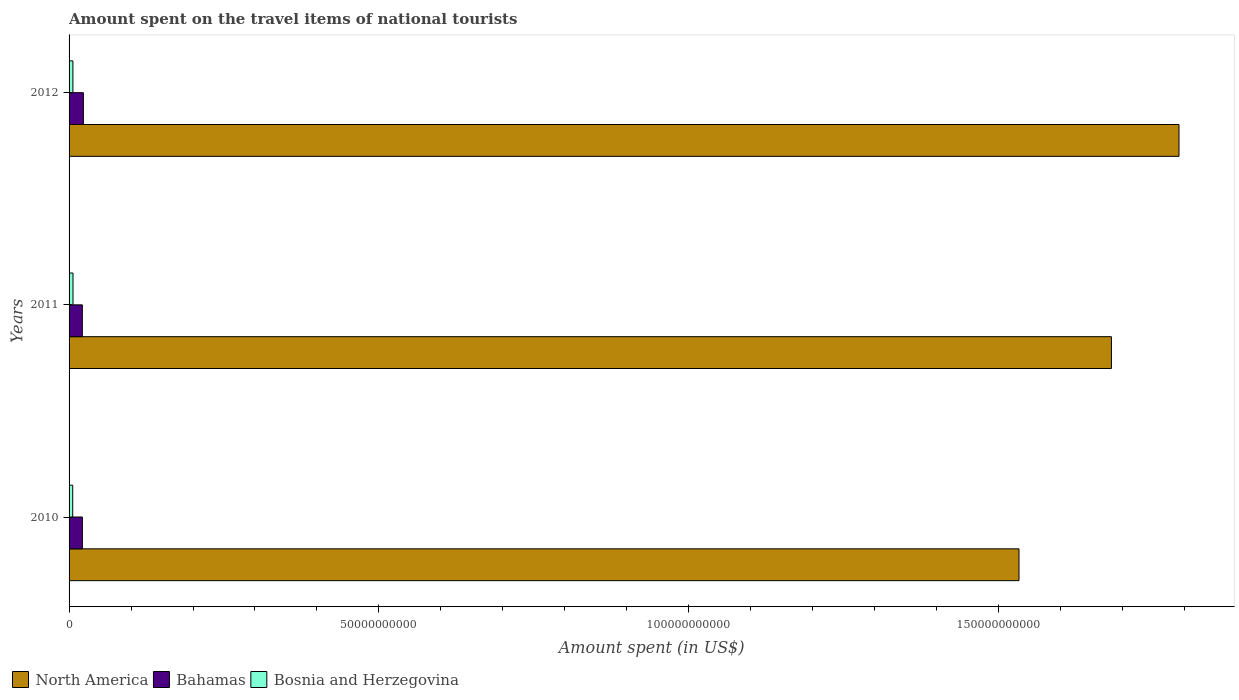Are the number of bars per tick equal to the number of legend labels?
Ensure brevity in your answer.  Yes. How many bars are there on the 2nd tick from the top?
Give a very brief answer. 3. How many bars are there on the 2nd tick from the bottom?
Give a very brief answer. 3. In how many cases, is the number of bars for a given year not equal to the number of legend labels?
Give a very brief answer. 0. What is the amount spent on the travel items of national tourists in North America in 2010?
Offer a terse response. 1.53e+11. Across all years, what is the maximum amount spent on the travel items of national tourists in North America?
Give a very brief answer. 1.79e+11. Across all years, what is the minimum amount spent on the travel items of national tourists in Bosnia and Herzegovina?
Make the answer very short. 5.89e+08. In which year was the amount spent on the travel items of national tourists in Bosnia and Herzegovina minimum?
Offer a very short reply. 2010. What is the total amount spent on the travel items of national tourists in Bosnia and Herzegovina in the graph?
Keep it short and to the point. 1.84e+09. What is the difference between the amount spent on the travel items of national tourists in North America in 2010 and that in 2012?
Your answer should be very brief. -2.58e+1. What is the difference between the amount spent on the travel items of national tourists in North America in 2011 and the amount spent on the travel items of national tourists in Bosnia and Herzegovina in 2012?
Offer a very short reply. 1.68e+11. What is the average amount spent on the travel items of national tourists in Bosnia and Herzegovina per year?
Offer a terse response. 6.14e+08. In the year 2012, what is the difference between the amount spent on the travel items of national tourists in North America and amount spent on the travel items of national tourists in Bosnia and Herzegovina?
Provide a succinct answer. 1.78e+11. What is the ratio of the amount spent on the travel items of national tourists in North America in 2010 to that in 2011?
Your response must be concise. 0.91. Is the difference between the amount spent on the travel items of national tourists in North America in 2011 and 2012 greater than the difference between the amount spent on the travel items of national tourists in Bosnia and Herzegovina in 2011 and 2012?
Your response must be concise. No. What is the difference between the highest and the second highest amount spent on the travel items of national tourists in Bosnia and Herzegovina?
Offer a very short reply. 1.70e+07. What is the difference between the highest and the lowest amount spent on the travel items of national tourists in Bahamas?
Make the answer very short. 1.69e+08. In how many years, is the amount spent on the travel items of national tourists in Bosnia and Herzegovina greater than the average amount spent on the travel items of national tourists in Bosnia and Herzegovina taken over all years?
Your answer should be very brief. 2. Is the sum of the amount spent on the travel items of national tourists in North America in 2010 and 2012 greater than the maximum amount spent on the travel items of national tourists in Bosnia and Herzegovina across all years?
Provide a succinct answer. Yes. What does the 2nd bar from the top in 2010 represents?
Keep it short and to the point. Bahamas. What does the 3rd bar from the bottom in 2010 represents?
Give a very brief answer. Bosnia and Herzegovina. How many bars are there?
Your answer should be very brief. 9. Are all the bars in the graph horizontal?
Your answer should be very brief. Yes. What is the difference between two consecutive major ticks on the X-axis?
Provide a succinct answer. 5.00e+1. Are the values on the major ticks of X-axis written in scientific E-notation?
Provide a succinct answer. No. Does the graph contain grids?
Keep it short and to the point. No. How are the legend labels stacked?
Offer a terse response. Horizontal. What is the title of the graph?
Your answer should be very brief. Amount spent on the travel items of national tourists. What is the label or title of the X-axis?
Keep it short and to the point. Amount spent (in US$). What is the label or title of the Y-axis?
Your answer should be compact. Years. What is the Amount spent (in US$) in North America in 2010?
Your response must be concise. 1.53e+11. What is the Amount spent (in US$) of Bahamas in 2010?
Provide a succinct answer. 2.15e+09. What is the Amount spent (in US$) in Bosnia and Herzegovina in 2010?
Provide a succinct answer. 5.89e+08. What is the Amount spent (in US$) in North America in 2011?
Give a very brief answer. 1.68e+11. What is the Amount spent (in US$) of Bahamas in 2011?
Provide a succinct answer. 2.14e+09. What is the Amount spent (in US$) in Bosnia and Herzegovina in 2011?
Give a very brief answer. 6.35e+08. What is the Amount spent (in US$) of North America in 2012?
Give a very brief answer. 1.79e+11. What is the Amount spent (in US$) of Bahamas in 2012?
Your response must be concise. 2.31e+09. What is the Amount spent (in US$) of Bosnia and Herzegovina in 2012?
Make the answer very short. 6.18e+08. Across all years, what is the maximum Amount spent (in US$) in North America?
Make the answer very short. 1.79e+11. Across all years, what is the maximum Amount spent (in US$) in Bahamas?
Provide a succinct answer. 2.31e+09. Across all years, what is the maximum Amount spent (in US$) in Bosnia and Herzegovina?
Provide a short and direct response. 6.35e+08. Across all years, what is the minimum Amount spent (in US$) in North America?
Your answer should be very brief. 1.53e+11. Across all years, what is the minimum Amount spent (in US$) of Bahamas?
Provide a short and direct response. 2.14e+09. Across all years, what is the minimum Amount spent (in US$) in Bosnia and Herzegovina?
Provide a succinct answer. 5.89e+08. What is the total Amount spent (in US$) of North America in the graph?
Offer a terse response. 5.01e+11. What is the total Amount spent (in US$) in Bahamas in the graph?
Provide a short and direct response. 6.60e+09. What is the total Amount spent (in US$) in Bosnia and Herzegovina in the graph?
Provide a succinct answer. 1.84e+09. What is the difference between the Amount spent (in US$) in North America in 2010 and that in 2011?
Your response must be concise. -1.49e+1. What is the difference between the Amount spent (in US$) of Bosnia and Herzegovina in 2010 and that in 2011?
Your answer should be very brief. -4.60e+07. What is the difference between the Amount spent (in US$) in North America in 2010 and that in 2012?
Your answer should be very brief. -2.58e+1. What is the difference between the Amount spent (in US$) of Bahamas in 2010 and that in 2012?
Give a very brief answer. -1.64e+08. What is the difference between the Amount spent (in US$) in Bosnia and Herzegovina in 2010 and that in 2012?
Your answer should be very brief. -2.90e+07. What is the difference between the Amount spent (in US$) of North America in 2011 and that in 2012?
Keep it short and to the point. -1.09e+1. What is the difference between the Amount spent (in US$) in Bahamas in 2011 and that in 2012?
Your answer should be very brief. -1.69e+08. What is the difference between the Amount spent (in US$) in Bosnia and Herzegovina in 2011 and that in 2012?
Offer a terse response. 1.70e+07. What is the difference between the Amount spent (in US$) of North America in 2010 and the Amount spent (in US$) of Bahamas in 2011?
Ensure brevity in your answer.  1.51e+11. What is the difference between the Amount spent (in US$) of North America in 2010 and the Amount spent (in US$) of Bosnia and Herzegovina in 2011?
Provide a short and direct response. 1.53e+11. What is the difference between the Amount spent (in US$) in Bahamas in 2010 and the Amount spent (in US$) in Bosnia and Herzegovina in 2011?
Offer a terse response. 1.51e+09. What is the difference between the Amount spent (in US$) of North America in 2010 and the Amount spent (in US$) of Bahamas in 2012?
Provide a succinct answer. 1.51e+11. What is the difference between the Amount spent (in US$) in North America in 2010 and the Amount spent (in US$) in Bosnia and Herzegovina in 2012?
Provide a succinct answer. 1.53e+11. What is the difference between the Amount spent (in US$) in Bahamas in 2010 and the Amount spent (in US$) in Bosnia and Herzegovina in 2012?
Offer a very short reply. 1.53e+09. What is the difference between the Amount spent (in US$) of North America in 2011 and the Amount spent (in US$) of Bahamas in 2012?
Your answer should be compact. 1.66e+11. What is the difference between the Amount spent (in US$) in North America in 2011 and the Amount spent (in US$) in Bosnia and Herzegovina in 2012?
Your answer should be very brief. 1.68e+11. What is the difference between the Amount spent (in US$) of Bahamas in 2011 and the Amount spent (in US$) of Bosnia and Herzegovina in 2012?
Your answer should be compact. 1.52e+09. What is the average Amount spent (in US$) of North America per year?
Your answer should be compact. 1.67e+11. What is the average Amount spent (in US$) of Bahamas per year?
Give a very brief answer. 2.20e+09. What is the average Amount spent (in US$) in Bosnia and Herzegovina per year?
Your response must be concise. 6.14e+08. In the year 2010, what is the difference between the Amount spent (in US$) in North America and Amount spent (in US$) in Bahamas?
Your response must be concise. 1.51e+11. In the year 2010, what is the difference between the Amount spent (in US$) of North America and Amount spent (in US$) of Bosnia and Herzegovina?
Provide a short and direct response. 1.53e+11. In the year 2010, what is the difference between the Amount spent (in US$) in Bahamas and Amount spent (in US$) in Bosnia and Herzegovina?
Your answer should be compact. 1.56e+09. In the year 2011, what is the difference between the Amount spent (in US$) in North America and Amount spent (in US$) in Bahamas?
Give a very brief answer. 1.66e+11. In the year 2011, what is the difference between the Amount spent (in US$) in North America and Amount spent (in US$) in Bosnia and Herzegovina?
Your response must be concise. 1.68e+11. In the year 2011, what is the difference between the Amount spent (in US$) in Bahamas and Amount spent (in US$) in Bosnia and Herzegovina?
Provide a succinct answer. 1.51e+09. In the year 2012, what is the difference between the Amount spent (in US$) of North America and Amount spent (in US$) of Bahamas?
Provide a succinct answer. 1.77e+11. In the year 2012, what is the difference between the Amount spent (in US$) in North America and Amount spent (in US$) in Bosnia and Herzegovina?
Make the answer very short. 1.78e+11. In the year 2012, what is the difference between the Amount spent (in US$) of Bahamas and Amount spent (in US$) of Bosnia and Herzegovina?
Provide a succinct answer. 1.69e+09. What is the ratio of the Amount spent (in US$) in North America in 2010 to that in 2011?
Keep it short and to the point. 0.91. What is the ratio of the Amount spent (in US$) of Bahamas in 2010 to that in 2011?
Give a very brief answer. 1. What is the ratio of the Amount spent (in US$) of Bosnia and Herzegovina in 2010 to that in 2011?
Give a very brief answer. 0.93. What is the ratio of the Amount spent (in US$) in North America in 2010 to that in 2012?
Your response must be concise. 0.86. What is the ratio of the Amount spent (in US$) in Bahamas in 2010 to that in 2012?
Your answer should be very brief. 0.93. What is the ratio of the Amount spent (in US$) of Bosnia and Herzegovina in 2010 to that in 2012?
Give a very brief answer. 0.95. What is the ratio of the Amount spent (in US$) in North America in 2011 to that in 2012?
Your answer should be compact. 0.94. What is the ratio of the Amount spent (in US$) of Bahamas in 2011 to that in 2012?
Offer a very short reply. 0.93. What is the ratio of the Amount spent (in US$) in Bosnia and Herzegovina in 2011 to that in 2012?
Offer a very short reply. 1.03. What is the difference between the highest and the second highest Amount spent (in US$) in North America?
Offer a very short reply. 1.09e+1. What is the difference between the highest and the second highest Amount spent (in US$) of Bahamas?
Your answer should be very brief. 1.64e+08. What is the difference between the highest and the second highest Amount spent (in US$) of Bosnia and Herzegovina?
Provide a succinct answer. 1.70e+07. What is the difference between the highest and the lowest Amount spent (in US$) in North America?
Give a very brief answer. 2.58e+1. What is the difference between the highest and the lowest Amount spent (in US$) in Bahamas?
Make the answer very short. 1.69e+08. What is the difference between the highest and the lowest Amount spent (in US$) of Bosnia and Herzegovina?
Provide a succinct answer. 4.60e+07. 